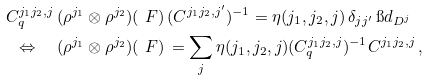Convert formula to latex. <formula><loc_0><loc_0><loc_500><loc_500>C _ { q } ^ { j _ { 1 } j _ { 2 } , j } \, ( \rho ^ { j _ { 1 } } \otimes \rho ^ { j _ { 2 } } ) ( & \ F ) \, ( C ^ { j _ { 1 } j _ { 2 } , j ^ { \prime } } ) ^ { - 1 } = \eta ( j _ { 1 } , j _ { 2 } , j ) \, \delta _ { j j ^ { \prime } } \, \i d _ { D ^ { j } } \\ \Leftrightarrow \quad ( \rho ^ { j _ { 1 } } \otimes \rho ^ { j _ { 2 } } ) ( & \ F ) \, = \sum _ { j } \eta ( j _ { 1 } , j _ { 2 } , j ) ( C _ { q } ^ { j _ { 1 } j _ { 2 } , j } ) ^ { - 1 } C ^ { j _ { 1 } j _ { 2 } , j } \, ,</formula> 